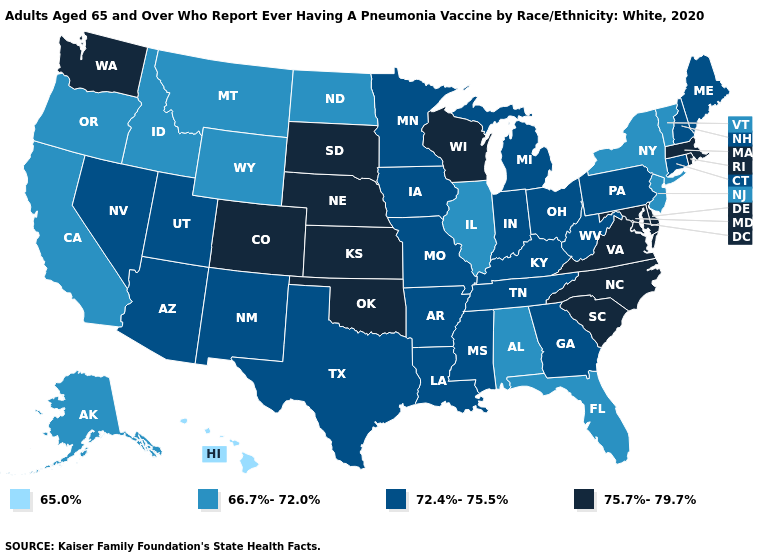What is the value of Tennessee?
Concise answer only. 72.4%-75.5%. What is the value of Georgia?
Give a very brief answer. 72.4%-75.5%. Name the states that have a value in the range 66.7%-72.0%?
Concise answer only. Alabama, Alaska, California, Florida, Idaho, Illinois, Montana, New Jersey, New York, North Dakota, Oregon, Vermont, Wyoming. Does Oregon have the lowest value in the USA?
Write a very short answer. No. Name the states that have a value in the range 65.0%?
Be succinct. Hawaii. Does the map have missing data?
Quick response, please. No. What is the value of New Hampshire?
Quick response, please. 72.4%-75.5%. Name the states that have a value in the range 65.0%?
Answer briefly. Hawaii. Does Louisiana have a lower value than Massachusetts?
Write a very short answer. Yes. Does Virginia have the highest value in the USA?
Be succinct. Yes. Name the states that have a value in the range 75.7%-79.7%?
Quick response, please. Colorado, Delaware, Kansas, Maryland, Massachusetts, Nebraska, North Carolina, Oklahoma, Rhode Island, South Carolina, South Dakota, Virginia, Washington, Wisconsin. Name the states that have a value in the range 75.7%-79.7%?
Quick response, please. Colorado, Delaware, Kansas, Maryland, Massachusetts, Nebraska, North Carolina, Oklahoma, Rhode Island, South Carolina, South Dakota, Virginia, Washington, Wisconsin. Name the states that have a value in the range 75.7%-79.7%?
Give a very brief answer. Colorado, Delaware, Kansas, Maryland, Massachusetts, Nebraska, North Carolina, Oklahoma, Rhode Island, South Carolina, South Dakota, Virginia, Washington, Wisconsin. How many symbols are there in the legend?
Write a very short answer. 4. Name the states that have a value in the range 65.0%?
Concise answer only. Hawaii. 